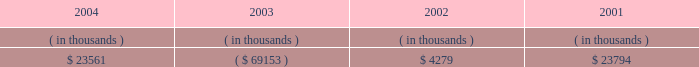Entergy arkansas , inc .
Management's financial discussion and analysis operating activities cash flow from operations increased $ 8.8 million in 2004 compared to 2003 primarily due to income tax benefits received in 2004 , and increased recovery of deferred fuel costs .
This increase was substantially offset by money pool activity .
In 2003 , the domestic utility companies and system energy filed , with the irs , a change in tax accounting method notification for their respective calculations of cost of goods sold .
The adjustment implemented a simplified method of allocation of overhead to the production of electricity , which is provided under the irs capitalization regulations .
The cumulative adjustment placing these companies on the new methodology resulted in a $ 1.171 billion deduction for entergy arkansas on entergy's 2003 income tax return .
There was no cash benefit from the method change in 2003 .
In 2004 , entergy arkansas realized $ 173 million in cash tax benefit from the method change .
This tax accounting method change is an issue across the utility industry and will likely be challenged by the irs on audit .
As of december 31 , 2004 , entergy arkansas has a net operating loss ( nol ) carryforward for tax purposes of $ 766.9 million , principally resulting from the change in tax accounting method related to cost of goods sold .
If the tax accounting method change is sustained , entergy arkansas expects to utilize the nol carryforward through 2006 .
Cash flow from operations increased $ 80.1 million in 2003 compared to 2002 primarily due to income taxes paid of $ 2.2 million in 2003 compared to income taxes paid of $ 83.9 million in 2002 , and money pool activity .
This increase was partially offset by decreased recovery of deferred fuel costs in 2003 .
Entergy arkansas' receivables from or ( payables to ) the money pool were as follows as of december 31 for each of the following years: .
Money pool activity used $ 92.7 million of entergy arkansas' operating cash flow in 2004 , provided $ 73.4 million in 2003 , and provided $ 19.5 million in 2002 .
See note 4 to the domestic utility companies and system energy financial statements for a description of the money pool .
Investing activities the decrease of $ 68.1 million in net cash used in investing activities in 2004 compared to 2003 was primarily due to a decrease in construction expenditures resulting from less transmission upgrade work requested by merchant generators in 2004 combined with lower spending on customer support projects in 2004 .
The increase of $ 88.1 million in net cash used in investing activities in 2003 compared to 2002 was primarily due to an increase in construction expenditures of $ 57.4 million and the maturity of $ 38.4 million of other temporary investments in the first quarter of 2002 .
Construction expenditures increased in 2003 primarily due to the following : 2022 a ferc ruling that shifted responsibility for transmission upgrade work performed for independent power producers to entergy arkansas ; and 2022 the ano 1 steam generator , reactor vessel head , and transformer replacement project .
Financing activities the decrease of $ 90.7 million in net cash used in financing activities in 2004 compared to 2003 was primarily due to the net redemption of $ 2.4 million of long-term debt in 2004 compared to $ 109.3 million in 2003 , partially offset by the payment of $ 16.2 million more in common stock dividends during the same period. .
What is the increase in construction expenditures as a percentage of the increase in net cash used in investing activities in 2003? 
Computations: (57.4 / 88.1)
Answer: 0.65153. 